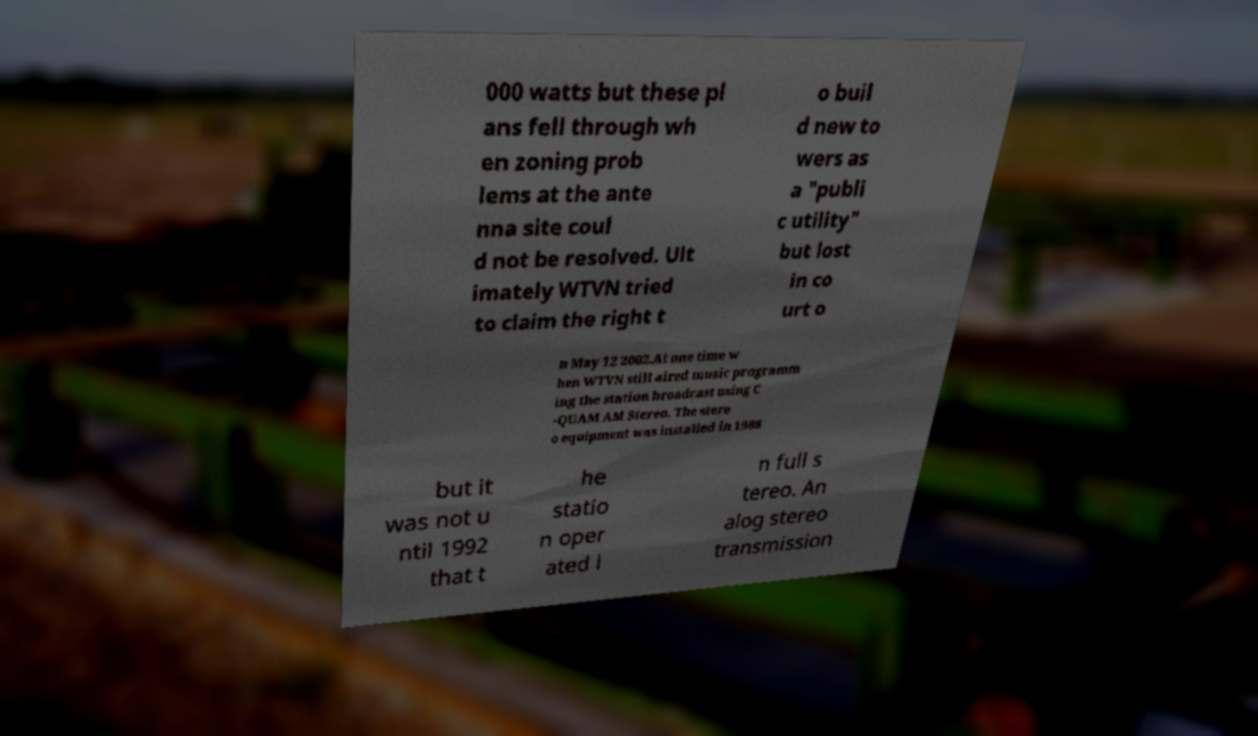Could you extract and type out the text from this image? 000 watts but these pl ans fell through wh en zoning prob lems at the ante nna site coul d not be resolved. Ult imately WTVN tried to claim the right t o buil d new to wers as a "publi c utility" but lost in co urt o n May 12 2002.At one time w hen WTVN still aired music programm ing the station broadcast using C -QUAM AM Stereo. The stere o equipment was installed in 1988 but it was not u ntil 1992 that t he statio n oper ated i n full s tereo. An alog stereo transmission 